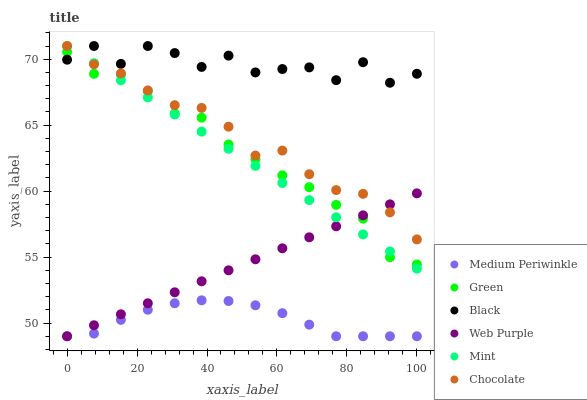Does Medium Periwinkle have the minimum area under the curve?
Answer yes or no. Yes. Does Black have the maximum area under the curve?
Answer yes or no. Yes. Does Chocolate have the minimum area under the curve?
Answer yes or no. No. Does Chocolate have the maximum area under the curve?
Answer yes or no. No. Is Mint the smoothest?
Answer yes or no. Yes. Is Black the roughest?
Answer yes or no. Yes. Is Chocolate the smoothest?
Answer yes or no. No. Is Chocolate the roughest?
Answer yes or no. No. Does Medium Periwinkle have the lowest value?
Answer yes or no. Yes. Does Chocolate have the lowest value?
Answer yes or no. No. Does Mint have the highest value?
Answer yes or no. Yes. Does Web Purple have the highest value?
Answer yes or no. No. Is Green less than Chocolate?
Answer yes or no. Yes. Is Mint greater than Medium Periwinkle?
Answer yes or no. Yes. Does Web Purple intersect Green?
Answer yes or no. Yes. Is Web Purple less than Green?
Answer yes or no. No. Is Web Purple greater than Green?
Answer yes or no. No. Does Green intersect Chocolate?
Answer yes or no. No. 